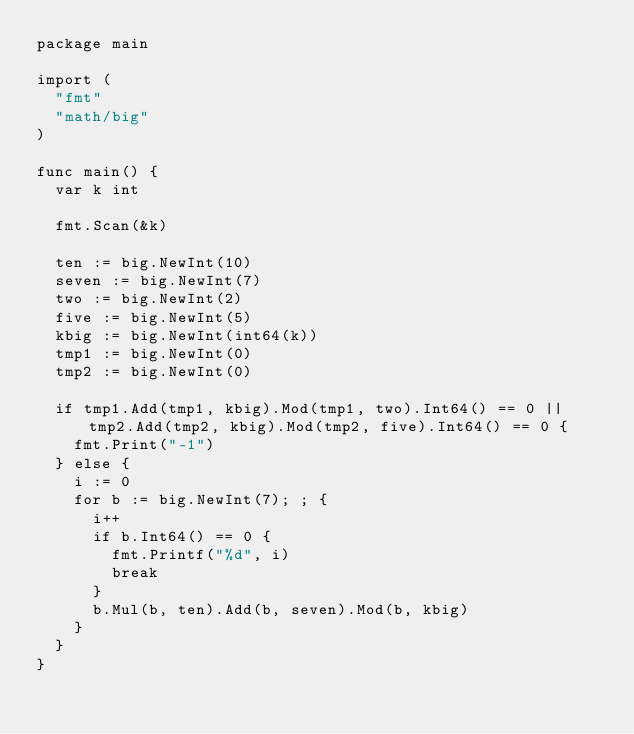Convert code to text. <code><loc_0><loc_0><loc_500><loc_500><_Go_>package main

import (
	"fmt"
	"math/big"
)

func main() {
	var k int

	fmt.Scan(&k)

	ten := big.NewInt(10)
	seven := big.NewInt(7)
	two := big.NewInt(2)
	five := big.NewInt(5)
	kbig := big.NewInt(int64(k))
	tmp1 := big.NewInt(0)
	tmp2 := big.NewInt(0)

	if tmp1.Add(tmp1, kbig).Mod(tmp1, two).Int64() == 0 || tmp2.Add(tmp2, kbig).Mod(tmp2, five).Int64() == 0 {
		fmt.Print("-1")
	} else {
		i := 0
		for b := big.NewInt(7); ; {
			i++
			if b.Int64() == 0 {
				fmt.Printf("%d", i)
				break
			}
			b.Mul(b, ten).Add(b, seven).Mod(b, kbig)
		}
	}
}
</code> 